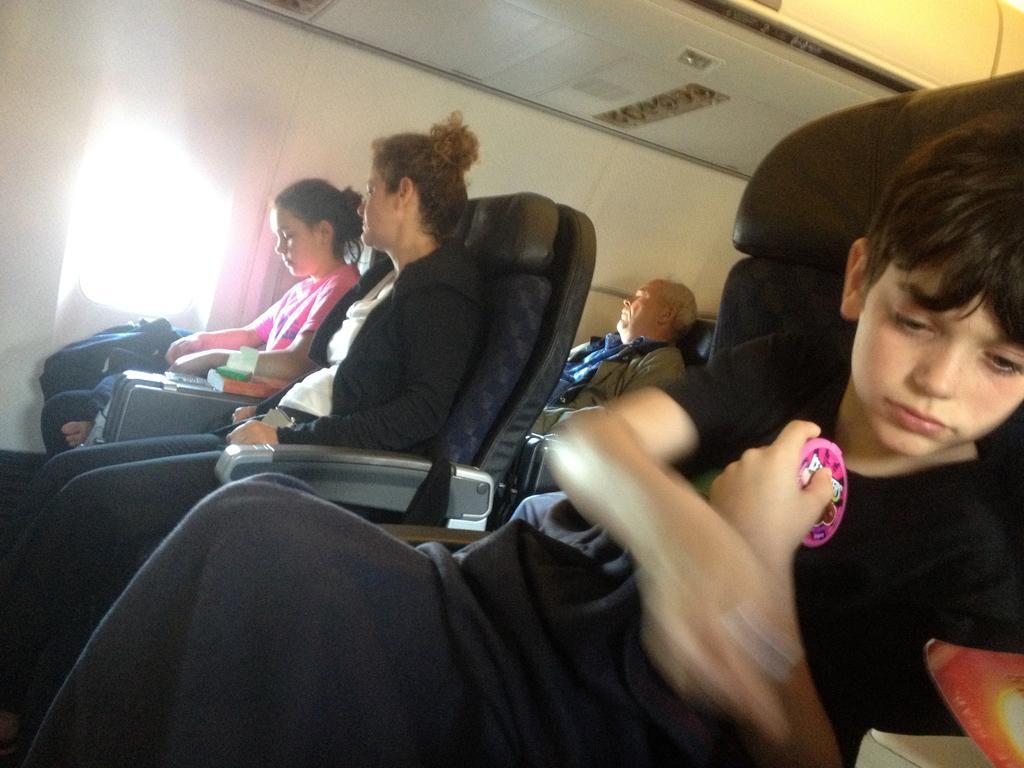Could you give a brief overview of what you see in this image? This picture is an inside view of a vehicle. In this picture we can see some people are sitting on the seats. At the bottom of the image we can see a boy is sitting on a seat and holding a toy. In the right corner we can see a book. On the left side of the image we can see a lady is holding a bag and also we can see the floor, book, window. At the top of the image we can see the roof. 